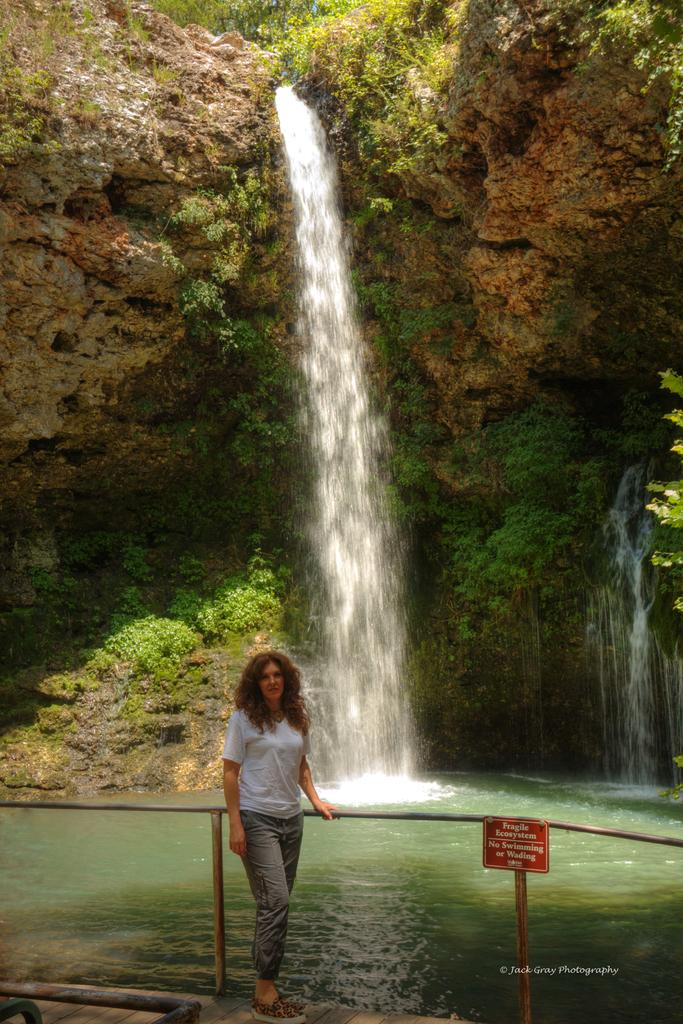What is the woman in the image doing? The woman is standing in the image and holding a rod. What can be seen in the background of the image? There is a waterfall in the background of the image. What is attached to a pole on the right side of the image? There is a board attached to a pole on the right side of the image. What type of lettuce is growing on the cushion in the image? There is no lettuce or cushion present in the image. 